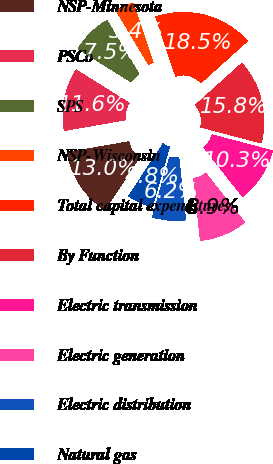Convert chart. <chart><loc_0><loc_0><loc_500><loc_500><pie_chart><fcel>NSP-Minnesota<fcel>PSCo<fcel>SPS<fcel>NSP-Wisconsin<fcel>Total capital expenditures<fcel>By Function<fcel>Electric transmission<fcel>Electric generation<fcel>Electric distribution<fcel>Natural gas<nl><fcel>13.01%<fcel>11.64%<fcel>7.54%<fcel>3.43%<fcel>18.48%<fcel>15.75%<fcel>10.27%<fcel>8.91%<fcel>6.17%<fcel>4.8%<nl></chart> 